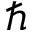Convert formula to latex. <formula><loc_0><loc_0><loc_500><loc_500>\hbar</formula> 